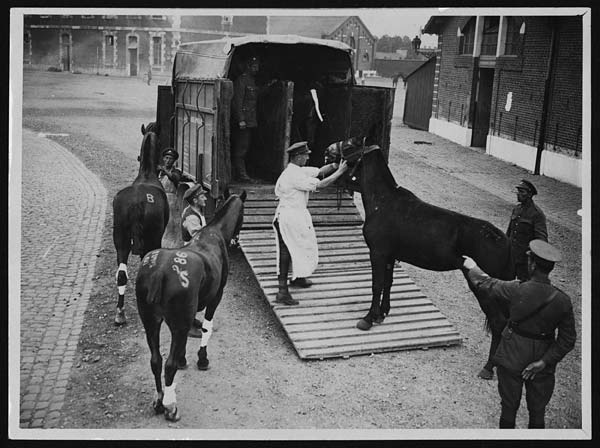Please identify all text content in this image. 8 S 286 